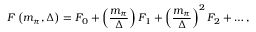<formula> <loc_0><loc_0><loc_500><loc_500>F \left ( m _ { \pi } , \Delta \right ) = F _ { 0 } + \left ( { \frac { m _ { \pi } } { \Delta } } \right ) F _ { 1 } + \left ( { \frac { m _ { \pi } } { \Delta } } \right ) ^ { 2 } F _ { 2 } + \dots ,</formula> 